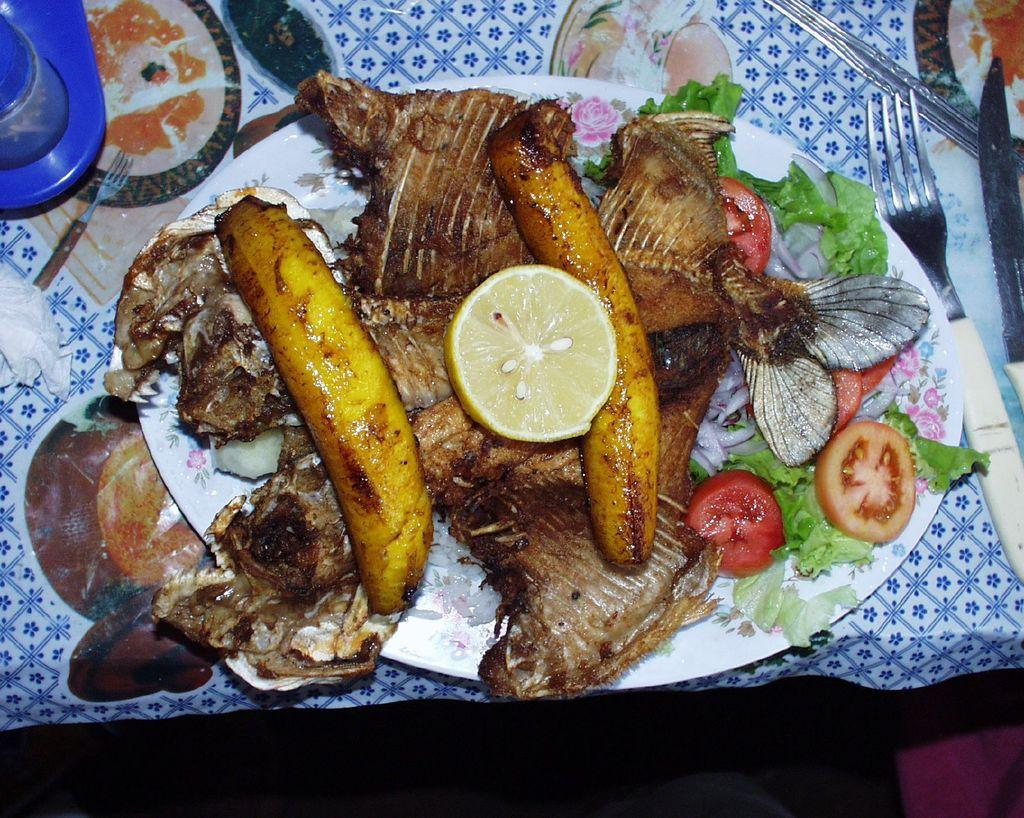What is located in the center of the image? There is a table in the center of the image. What is covering the table? There is a cloth on the table. What utensils can be seen on the table? There are forks on the table. What color is the object on the table? There is a blue color object on the table. What is used for serving food on the table? There is a plate on the table. What is being served on the table? There are food items on the table. How does the parent feel about the yak in the image? There is no yak or parent present in the image. 